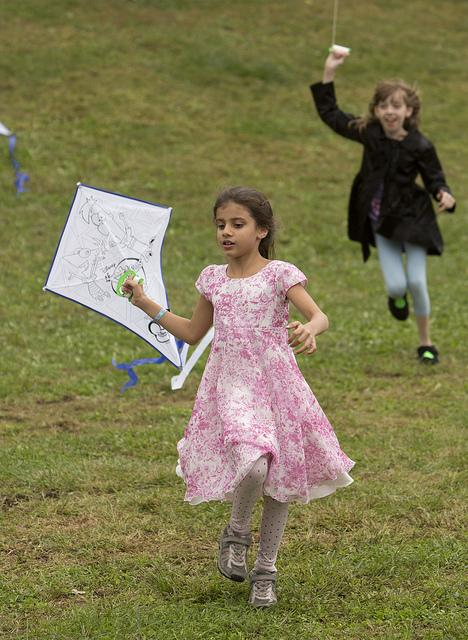What is the girl in pink wearing? Please explain your reasoning. dress. A young girl is holding a kite. she is wearing a long pink and white piece of clothing. 